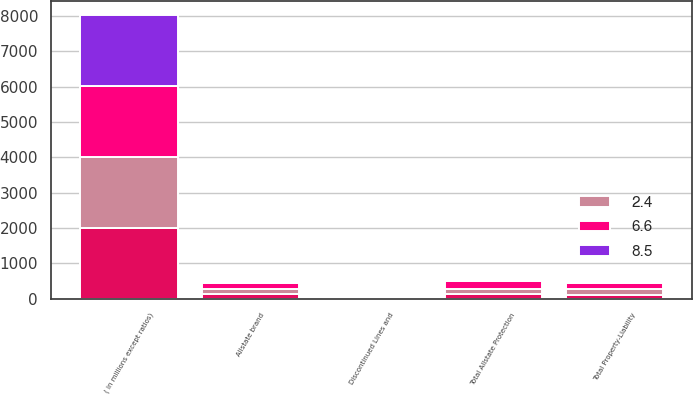Convert chart to OTSL. <chart><loc_0><loc_0><loc_500><loc_500><stacked_bar_chart><ecel><fcel>( in millions except ratios)<fcel>Allstate brand<fcel>Total Allstate Protection<fcel>Discontinued Lines and<fcel>Total Property-Liability<nl><fcel>nan<fcel>2009<fcel>126<fcel>136<fcel>24<fcel>112<nl><fcel>8.5<fcel>2009<fcel>0.5<fcel>0.5<fcel>0.1<fcel>0.4<nl><fcel>2.4<fcel>2008<fcel>155<fcel>152<fcel>18<fcel>170<nl><fcel>6.6<fcel>2007<fcel>167<fcel>219<fcel>47<fcel>172<nl></chart> 